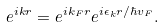<formula> <loc_0><loc_0><loc_500><loc_500>e ^ { i k r } = e ^ { i k _ { F } r } e ^ { i \epsilon _ { k } r / \hbar { v } _ { F } } .</formula> 